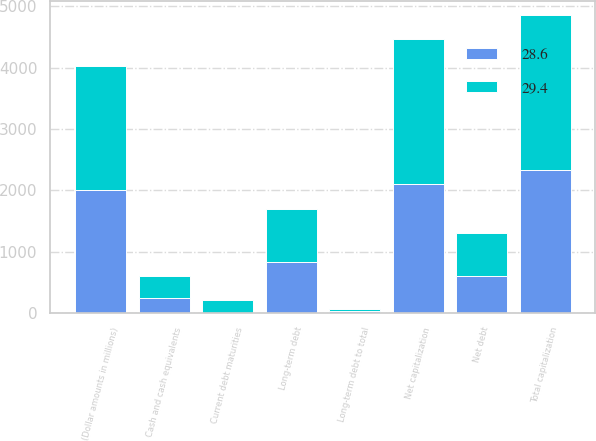Convert chart. <chart><loc_0><loc_0><loc_500><loc_500><stacked_bar_chart><ecel><fcel>(Dollar amounts in millions)<fcel>Long-term debt<fcel>Current debt maturities<fcel>Cash and cash equivalents<fcel>Net debt<fcel>Total capitalization<fcel>Net capitalization<fcel>Long-term debt to total<nl><fcel>29.4<fcel>2012<fcel>854<fcel>202<fcel>359<fcel>697<fcel>2524<fcel>2367<fcel>33.8<nl><fcel>28.6<fcel>2011<fcel>833<fcel>3<fcel>236<fcel>600<fcel>2329<fcel>2096<fcel>35.8<nl></chart> 